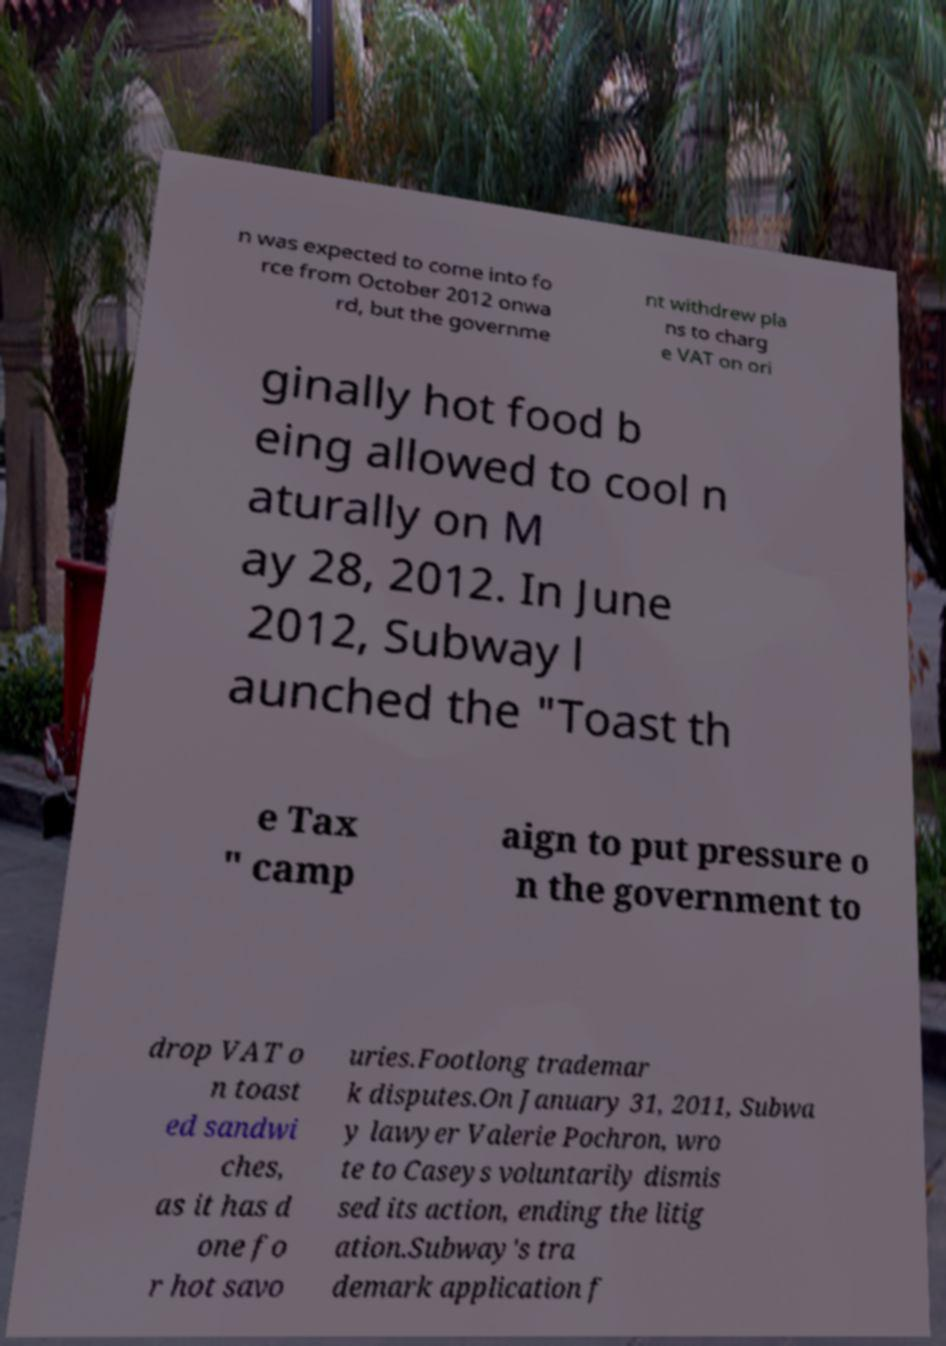Could you assist in decoding the text presented in this image and type it out clearly? n was expected to come into fo rce from October 2012 onwa rd, but the governme nt withdrew pla ns to charg e VAT on ori ginally hot food b eing allowed to cool n aturally on M ay 28, 2012. In June 2012, Subway l aunched the "Toast th e Tax " camp aign to put pressure o n the government to drop VAT o n toast ed sandwi ches, as it has d one fo r hot savo uries.Footlong trademar k disputes.On January 31, 2011, Subwa y lawyer Valerie Pochron, wro te to Caseys voluntarily dismis sed its action, ending the litig ation.Subway's tra demark application f 